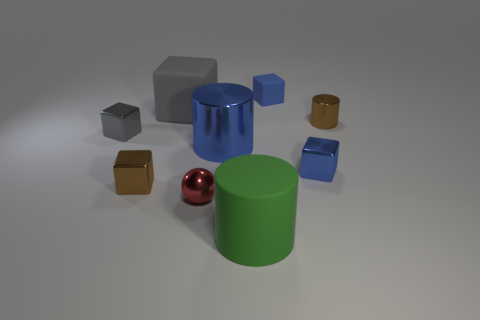Subtract all large blue metal cylinders. How many cylinders are left? 2 Subtract all blue blocks. How many blocks are left? 3 Subtract 2 gray blocks. How many objects are left? 7 Subtract all blocks. How many objects are left? 4 Subtract 2 cylinders. How many cylinders are left? 1 Subtract all gray cylinders. Subtract all purple spheres. How many cylinders are left? 3 Subtract all red balls. How many yellow cylinders are left? 0 Subtract all large gray rubber blocks. Subtract all blue metal things. How many objects are left? 6 Add 7 big blue metal things. How many big blue metal things are left? 8 Add 6 large cyan rubber blocks. How many large cyan rubber blocks exist? 6 